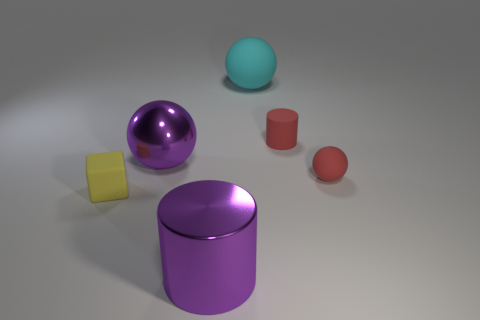How many matte objects are either red balls or large cyan objects?
Offer a terse response. 2. There is a yellow thing in front of the large ball right of the large purple shiny sphere; what number of big shiny cylinders are left of it?
Offer a terse response. 0. There is a red cylinder that is the same material as the small red sphere; what is its size?
Offer a terse response. Small. How many big metallic cylinders are the same color as the metallic sphere?
Give a very brief answer. 1. Does the purple shiny thing that is in front of the yellow matte object have the same size as the tiny matte cylinder?
Ensure brevity in your answer.  No. What is the color of the sphere that is both on the right side of the purple shiny cylinder and in front of the cyan sphere?
Your answer should be compact. Red. How many things are either large cylinders or small objects behind the large purple shiny cylinder?
Offer a very short reply. 4. What material is the large object in front of the purple metal object that is behind the cylinder that is in front of the tiny rubber cube?
Give a very brief answer. Metal. There is a cylinder that is on the right side of the cyan rubber object; does it have the same color as the tiny rubber sphere?
Make the answer very short. Yes. What number of green objects are small rubber spheres or small cubes?
Your answer should be compact. 0. 